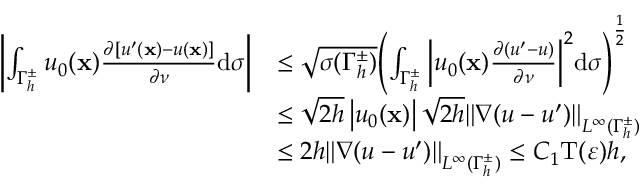Convert formula to latex. <formula><loc_0><loc_0><loc_500><loc_500>\begin{array} { r l } { \left | \int _ { { \Gamma _ { h } ^ { \pm } } } { { u _ { 0 } } ( \mathbf x ) { \frac { \partial [ u ^ { \prime } ( \mathbf x ) - u ( \mathbf x ) ] } { \partial \nu } } } \mathrm d \sigma \right | } & { \leq \sqrt { \sigma ( { \Gamma _ { h } ^ { \pm } } ) } { \left ( { \int _ { { \Gamma _ { h } ^ { \pm } } } { \left | { { u _ { 0 } } ( \mathbf x ) { \frac { \partial ( u ^ { \prime } - u ) } { \partial \nu } } } \right | } ^ { 2 } } \mathrm d \sigma \right ) ^ { { \frac { 1 } { 2 } } } } } \\ & { \leq \sqrt { 2 h } \left | { { u _ { 0 } } ( \mathbf x ) } \right | \sqrt { 2 h } { \left \| { \nabla ( u - u ^ { \prime } ) } \right \| _ { { L ^ { \infty } } ( { \Gamma _ { h } ^ { \pm } } ) } } } \\ & { \leq 2 h { \left \| { \nabla ( u - u ^ { \prime } ) } \right \| _ { { L ^ { \infty } } ( { \Gamma _ { h } ^ { \pm } } ) } } \leq C _ { 1 } \mathrm T ( \varepsilon ) h , } \end{array}</formula> 